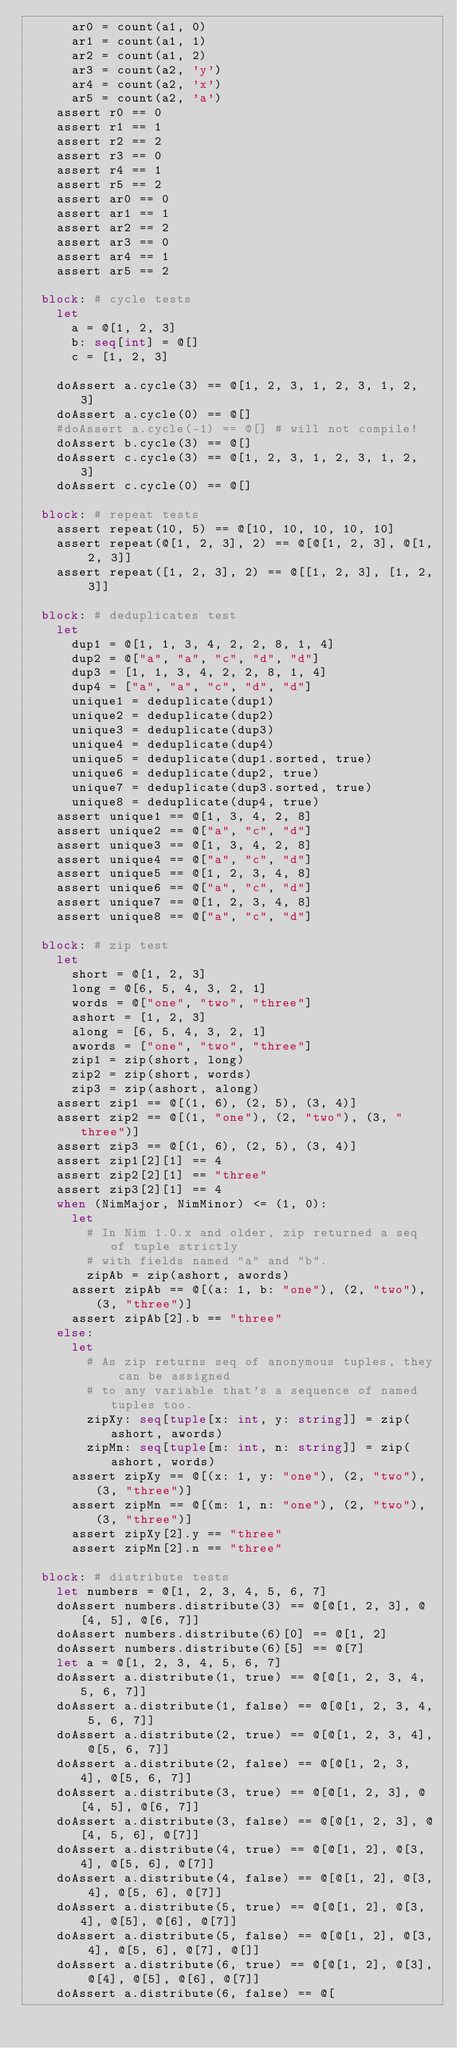<code> <loc_0><loc_0><loc_500><loc_500><_Nim_>      ar0 = count(a1, 0)
      ar1 = count(a1, 1)
      ar2 = count(a1, 2)
      ar3 = count(a2, 'y')
      ar4 = count(a2, 'x')
      ar5 = count(a2, 'a')
    assert r0 == 0
    assert r1 == 1
    assert r2 == 2
    assert r3 == 0
    assert r4 == 1
    assert r5 == 2
    assert ar0 == 0
    assert ar1 == 1
    assert ar2 == 2
    assert ar3 == 0
    assert ar4 == 1
    assert ar5 == 2

  block: # cycle tests
    let
      a = @[1, 2, 3]
      b: seq[int] = @[]
      c = [1, 2, 3]

    doAssert a.cycle(3) == @[1, 2, 3, 1, 2, 3, 1, 2, 3]
    doAssert a.cycle(0) == @[]
    #doAssert a.cycle(-1) == @[] # will not compile!
    doAssert b.cycle(3) == @[]
    doAssert c.cycle(3) == @[1, 2, 3, 1, 2, 3, 1, 2, 3]
    doAssert c.cycle(0) == @[]

  block: # repeat tests
    assert repeat(10, 5) == @[10, 10, 10, 10, 10]
    assert repeat(@[1, 2, 3], 2) == @[@[1, 2, 3], @[1, 2, 3]]
    assert repeat([1, 2, 3], 2) == @[[1, 2, 3], [1, 2, 3]]

  block: # deduplicates test
    let
      dup1 = @[1, 1, 3, 4, 2, 2, 8, 1, 4]
      dup2 = @["a", "a", "c", "d", "d"]
      dup3 = [1, 1, 3, 4, 2, 2, 8, 1, 4]
      dup4 = ["a", "a", "c", "d", "d"]
      unique1 = deduplicate(dup1)
      unique2 = deduplicate(dup2)
      unique3 = deduplicate(dup3)
      unique4 = deduplicate(dup4)
      unique5 = deduplicate(dup1.sorted, true)
      unique6 = deduplicate(dup2, true)
      unique7 = deduplicate(dup3.sorted, true)
      unique8 = deduplicate(dup4, true)
    assert unique1 == @[1, 3, 4, 2, 8]
    assert unique2 == @["a", "c", "d"]
    assert unique3 == @[1, 3, 4, 2, 8]
    assert unique4 == @["a", "c", "d"]
    assert unique5 == @[1, 2, 3, 4, 8]
    assert unique6 == @["a", "c", "d"]
    assert unique7 == @[1, 2, 3, 4, 8]
    assert unique8 == @["a", "c", "d"]

  block: # zip test
    let
      short = @[1, 2, 3]
      long = @[6, 5, 4, 3, 2, 1]
      words = @["one", "two", "three"]
      ashort = [1, 2, 3]
      along = [6, 5, 4, 3, 2, 1]
      awords = ["one", "two", "three"]
      zip1 = zip(short, long)
      zip2 = zip(short, words)
      zip3 = zip(ashort, along)
    assert zip1 == @[(1, 6), (2, 5), (3, 4)]
    assert zip2 == @[(1, "one"), (2, "two"), (3, "three")]
    assert zip3 == @[(1, 6), (2, 5), (3, 4)]
    assert zip1[2][1] == 4
    assert zip2[2][1] == "three"
    assert zip3[2][1] == 4
    when (NimMajor, NimMinor) <= (1, 0):
      let
        # In Nim 1.0.x and older, zip returned a seq of tuple strictly
        # with fields named "a" and "b".
        zipAb = zip(ashort, awords)
      assert zipAb == @[(a: 1, b: "one"), (2, "two"), (3, "three")]
      assert zipAb[2].b == "three"
    else:
      let
        # As zip returns seq of anonymous tuples, they can be assigned
        # to any variable that's a sequence of named tuples too.
        zipXy: seq[tuple[x: int, y: string]] = zip(ashort, awords)
        zipMn: seq[tuple[m: int, n: string]] = zip(ashort, words)
      assert zipXy == @[(x: 1, y: "one"), (2, "two"), (3, "three")]
      assert zipMn == @[(m: 1, n: "one"), (2, "two"), (3, "three")]
      assert zipXy[2].y == "three"
      assert zipMn[2].n == "three"

  block: # distribute tests
    let numbers = @[1, 2, 3, 4, 5, 6, 7]
    doAssert numbers.distribute(3) == @[@[1, 2, 3], @[4, 5], @[6, 7]]
    doAssert numbers.distribute(6)[0] == @[1, 2]
    doAssert numbers.distribute(6)[5] == @[7]
    let a = @[1, 2, 3, 4, 5, 6, 7]
    doAssert a.distribute(1, true) == @[@[1, 2, 3, 4, 5, 6, 7]]
    doAssert a.distribute(1, false) == @[@[1, 2, 3, 4, 5, 6, 7]]
    doAssert a.distribute(2, true) == @[@[1, 2, 3, 4], @[5, 6, 7]]
    doAssert a.distribute(2, false) == @[@[1, 2, 3, 4], @[5, 6, 7]]
    doAssert a.distribute(3, true) == @[@[1, 2, 3], @[4, 5], @[6, 7]]
    doAssert a.distribute(3, false) == @[@[1, 2, 3], @[4, 5, 6], @[7]]
    doAssert a.distribute(4, true) == @[@[1, 2], @[3, 4], @[5, 6], @[7]]
    doAssert a.distribute(4, false) == @[@[1, 2], @[3, 4], @[5, 6], @[7]]
    doAssert a.distribute(5, true) == @[@[1, 2], @[3, 4], @[5], @[6], @[7]]
    doAssert a.distribute(5, false) == @[@[1, 2], @[3, 4], @[5, 6], @[7], @[]]
    doAssert a.distribute(6, true) == @[@[1, 2], @[3], @[4], @[5], @[6], @[7]]
    doAssert a.distribute(6, false) == @[</code> 